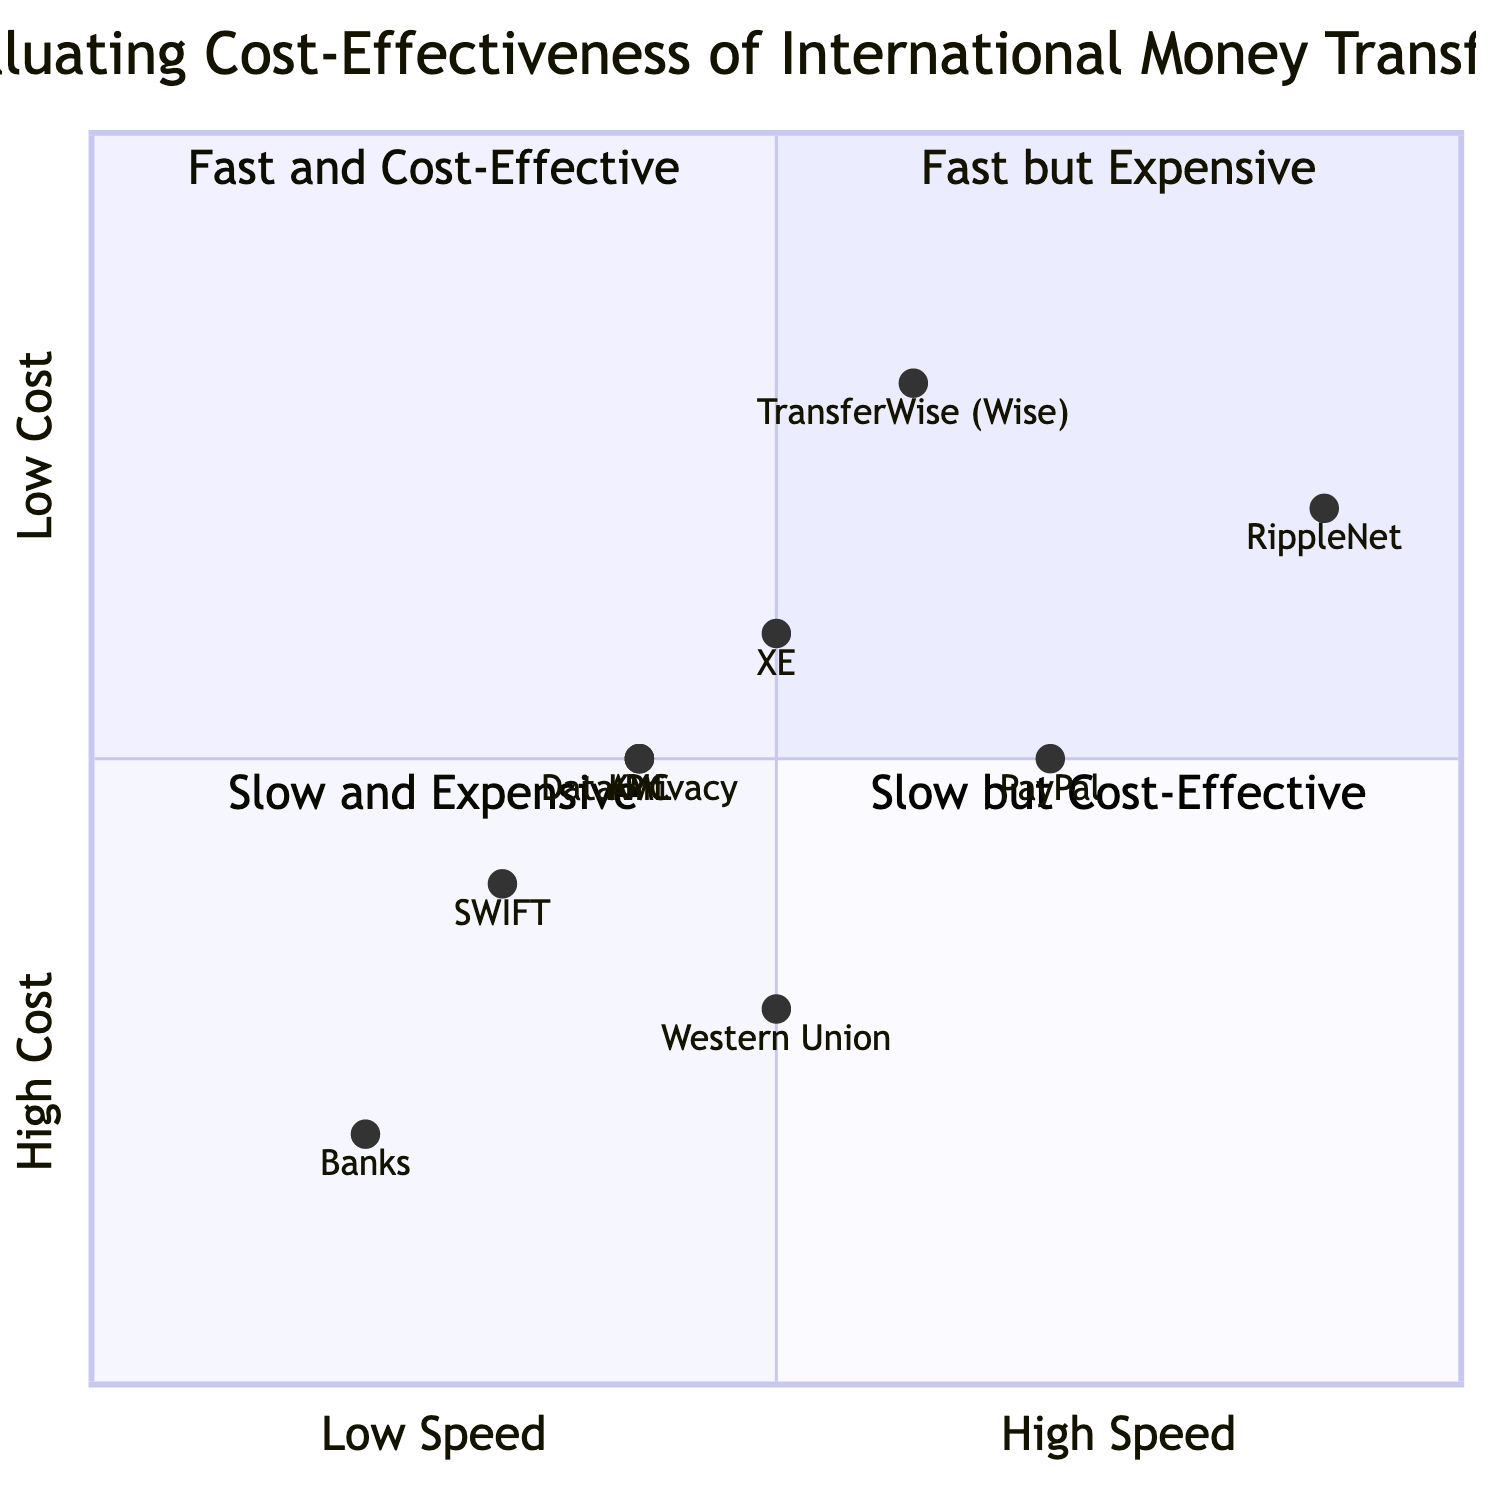What is the location of RippleNet in the quadrant chart? RippleNet is located in Quadrant 2, where it is categorized as "Fast and Cost-Effective," as it offers near-instantaneous transfers and has a high cost score.
Answer: Quadrant 2 Which transfer service has the highest fees? From the transfer services displayed, Banks typically have the highest fees compared to others, as they are generally represented with a lower cost rating.
Answer: Banks What is the average speed for SWIFT transfers? SWIFT transfers typically take between 1 to 5 business days, placing it in a slower speed category on the chart.
Answer: 1-5 business days How many services are categorized as "Slow but Cost-Effective"? The chart indicates that there are two services categorized as "Slow but Cost-Effective," as they fall into Quadrant 4 with lower speed and fee ratings.
Answer: 2 Which service provides mid-market exchange rates? TransferWise (Wise) is known for offering mid-market exchange rates, contributing to its cost-effectiveness in the chart.
Answer: TransferWise (Wise) What is the cost rating for Western Union? Western Union has a cost rating of 0.3, indicating it is relatively cost-effective compared to others in the chart.
Answer: 0.3 What quadrant does PayPal fall into? PayPal is located in Quadrant 2, categorized as "Fast and Cost-Effective," given its quick transfer speed and moderate cost structure.
Answer: Quadrant 2 Which services are subject to KYC compliance? KYC compliance is relevant for services like RippleNet and Banks, as these entities must adhere to customer identification requirements indicated in the compliance section.
Answer: RippleNet and Banks How does the exchange rate of Bank Exchange Rates compare to XE? Bank Exchange Rates generally include significant markups, while XE provides competitive rates with small margins. This shows that XE is more cost-effective in terms of exchange rates.
Answer: XE is more cost-effective 